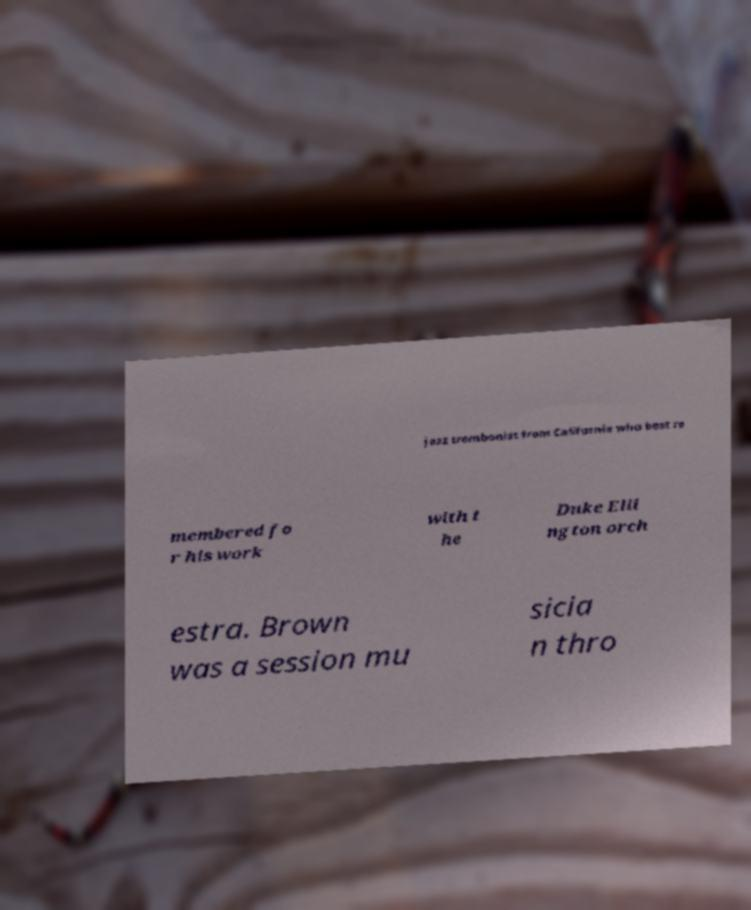Could you extract and type out the text from this image? jazz trombonist from California who best re membered fo r his work with t he Duke Elli ngton orch estra. Brown was a session mu sicia n thro 